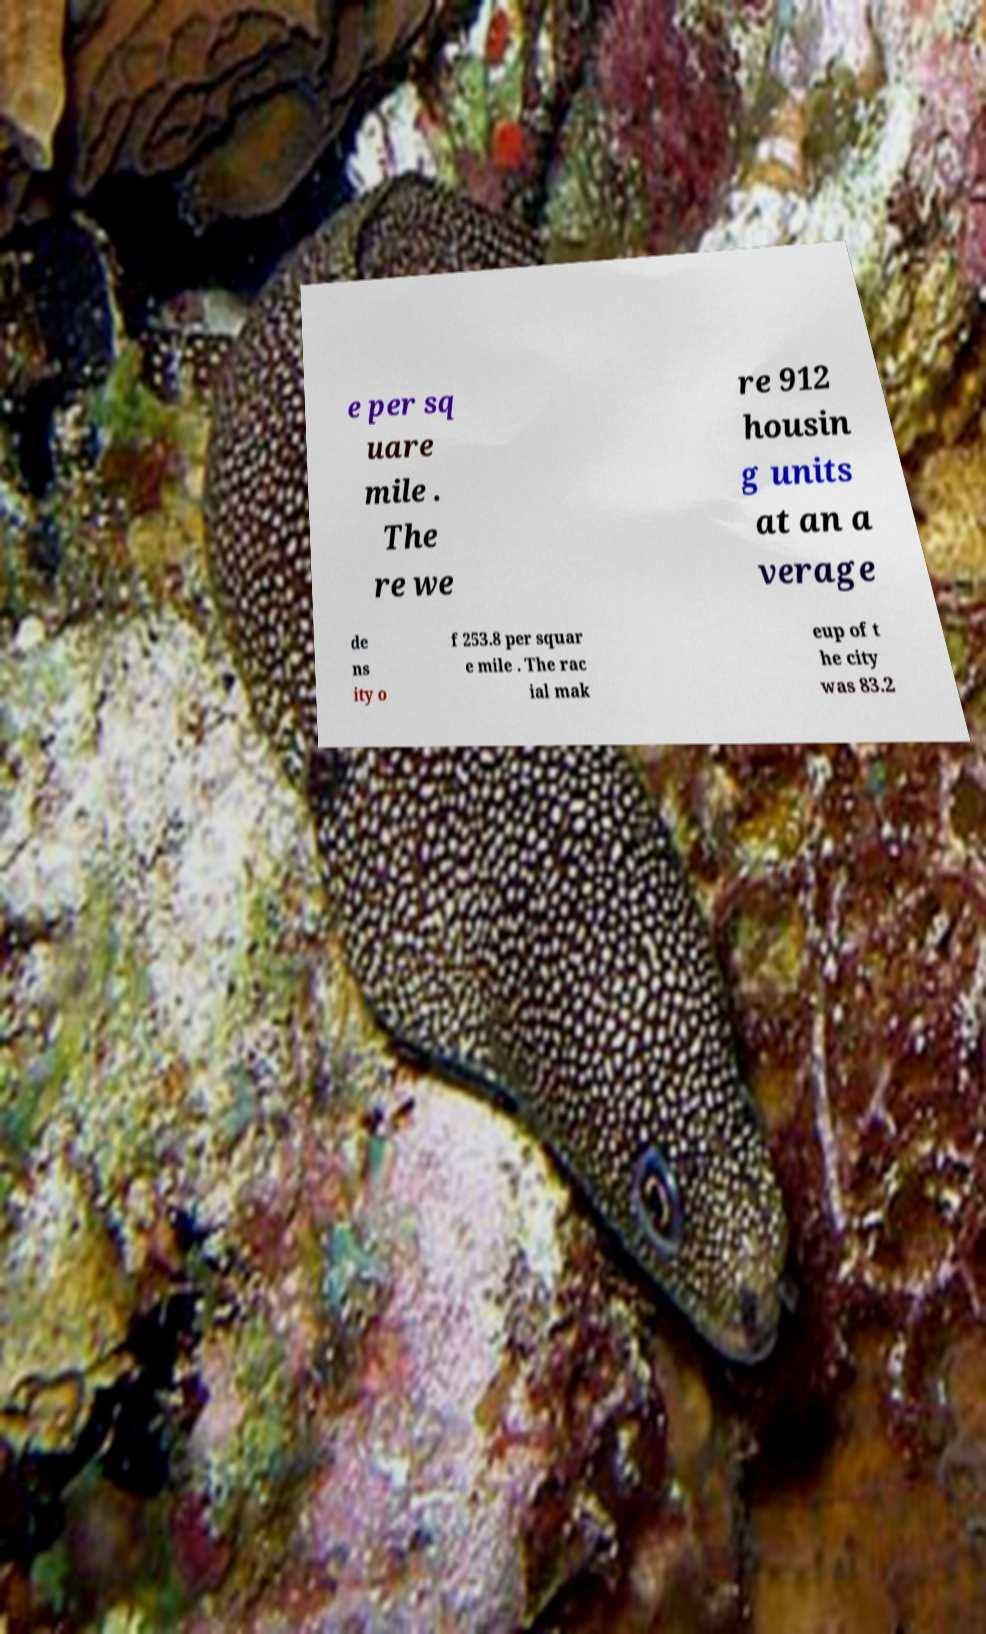I need the written content from this picture converted into text. Can you do that? e per sq uare mile . The re we re 912 housin g units at an a verage de ns ity o f 253.8 per squar e mile . The rac ial mak eup of t he city was 83.2 